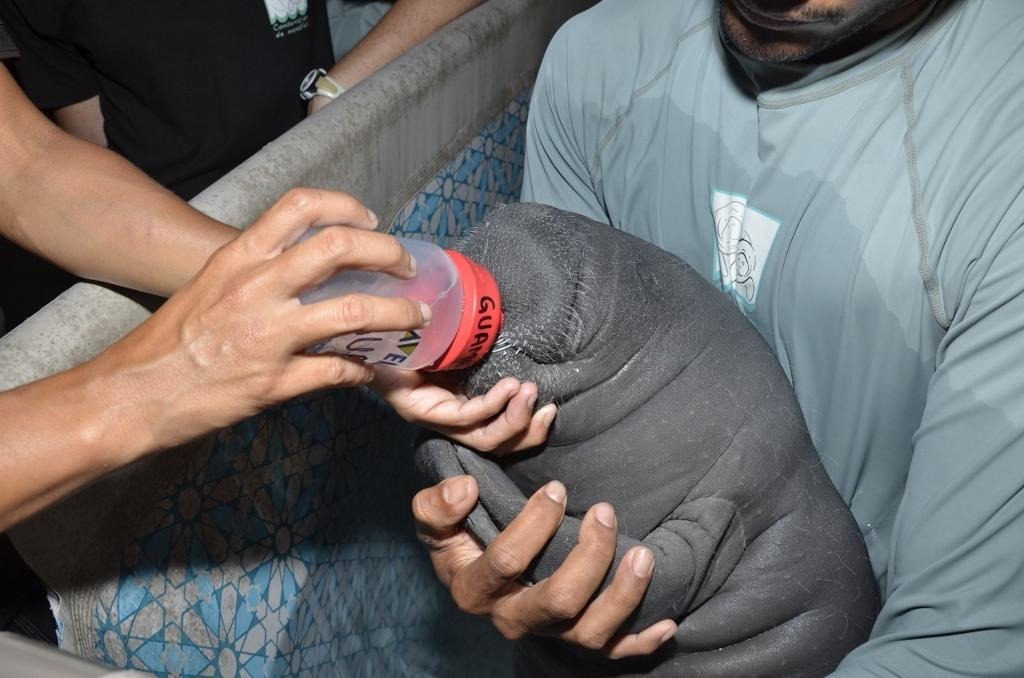What is the person in the image doing with the animal? The person is feeding the animal using a bottle. How is the bottle being held or supported during the feeding process? The bottle is on the lap of another person. Can you describe the people standing behind a chair in the image? There are other people standing behind a chair in the image. What type of bike is visible in the image? There is no bike present in the image. Can you describe the air quality in the image? The image does not provide any information about the air quality. 